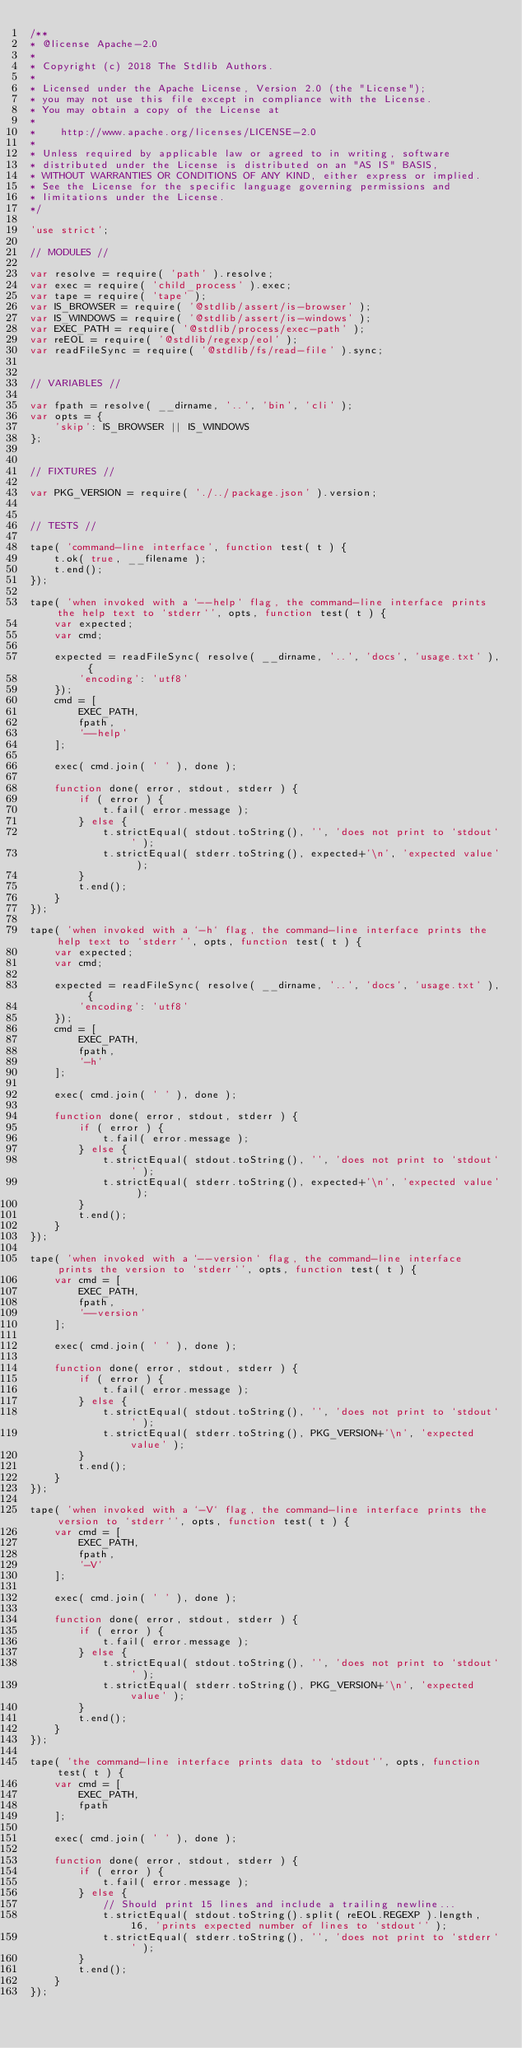<code> <loc_0><loc_0><loc_500><loc_500><_JavaScript_>/**
* @license Apache-2.0
*
* Copyright (c) 2018 The Stdlib Authors.
*
* Licensed under the Apache License, Version 2.0 (the "License");
* you may not use this file except in compliance with the License.
* You may obtain a copy of the License at
*
*    http://www.apache.org/licenses/LICENSE-2.0
*
* Unless required by applicable law or agreed to in writing, software
* distributed under the License is distributed on an "AS IS" BASIS,
* WITHOUT WARRANTIES OR CONDITIONS OF ANY KIND, either express or implied.
* See the License for the specific language governing permissions and
* limitations under the License.
*/

'use strict';

// MODULES //

var resolve = require( 'path' ).resolve;
var exec = require( 'child_process' ).exec;
var tape = require( 'tape' );
var IS_BROWSER = require( '@stdlib/assert/is-browser' );
var IS_WINDOWS = require( '@stdlib/assert/is-windows' );
var EXEC_PATH = require( '@stdlib/process/exec-path' );
var reEOL = require( '@stdlib/regexp/eol' );
var readFileSync = require( '@stdlib/fs/read-file' ).sync;


// VARIABLES //

var fpath = resolve( __dirname, '..', 'bin', 'cli' );
var opts = {
	'skip': IS_BROWSER || IS_WINDOWS
};


// FIXTURES //

var PKG_VERSION = require( './../package.json' ).version;


// TESTS //

tape( 'command-line interface', function test( t ) {
	t.ok( true, __filename );
	t.end();
});

tape( 'when invoked with a `--help` flag, the command-line interface prints the help text to `stderr`', opts, function test( t ) {
	var expected;
	var cmd;

	expected = readFileSync( resolve( __dirname, '..', 'docs', 'usage.txt' ), {
		'encoding': 'utf8'
	});
	cmd = [
		EXEC_PATH,
		fpath,
		'--help'
	];

	exec( cmd.join( ' ' ), done );

	function done( error, stdout, stderr ) {
		if ( error ) {
			t.fail( error.message );
		} else {
			t.strictEqual( stdout.toString(), '', 'does not print to `stdout`' );
			t.strictEqual( stderr.toString(), expected+'\n', 'expected value' );
		}
		t.end();
	}
});

tape( 'when invoked with a `-h` flag, the command-line interface prints the help text to `stderr`', opts, function test( t ) {
	var expected;
	var cmd;

	expected = readFileSync( resolve( __dirname, '..', 'docs', 'usage.txt' ), {
		'encoding': 'utf8'
	});
	cmd = [
		EXEC_PATH,
		fpath,
		'-h'
	];

	exec( cmd.join( ' ' ), done );

	function done( error, stdout, stderr ) {
		if ( error ) {
			t.fail( error.message );
		} else {
			t.strictEqual( stdout.toString(), '', 'does not print to `stdout`' );
			t.strictEqual( stderr.toString(), expected+'\n', 'expected value' );
		}
		t.end();
	}
});

tape( 'when invoked with a `--version` flag, the command-line interface prints the version to `stderr`', opts, function test( t ) {
	var cmd = [
		EXEC_PATH,
		fpath,
		'--version'
	];

	exec( cmd.join( ' ' ), done );

	function done( error, stdout, stderr ) {
		if ( error ) {
			t.fail( error.message );
		} else {
			t.strictEqual( stdout.toString(), '', 'does not print to `stdout`' );
			t.strictEqual( stderr.toString(), PKG_VERSION+'\n', 'expected value' );
		}
		t.end();
	}
});

tape( 'when invoked with a `-V` flag, the command-line interface prints the version to `stderr`', opts, function test( t ) {
	var cmd = [
		EXEC_PATH,
		fpath,
		'-V'
	];

	exec( cmd.join( ' ' ), done );

	function done( error, stdout, stderr ) {
		if ( error ) {
			t.fail( error.message );
		} else {
			t.strictEqual( stdout.toString(), '', 'does not print to `stdout`' );
			t.strictEqual( stderr.toString(), PKG_VERSION+'\n', 'expected value' );
		}
		t.end();
	}
});

tape( 'the command-line interface prints data to `stdout`', opts, function test( t ) {
	var cmd = [
		EXEC_PATH,
		fpath
	];

	exec( cmd.join( ' ' ), done );

	function done( error, stdout, stderr ) {
		if ( error ) {
			t.fail( error.message );
		} else {
			// Should print 15 lines and include a trailing newline...
			t.strictEqual( stdout.toString().split( reEOL.REGEXP ).length, 16, 'prints expected number of lines to `stdout`' );
			t.strictEqual( stderr.toString(), '', 'does not print to `stderr`' );
		}
		t.end();
	}
});
</code> 